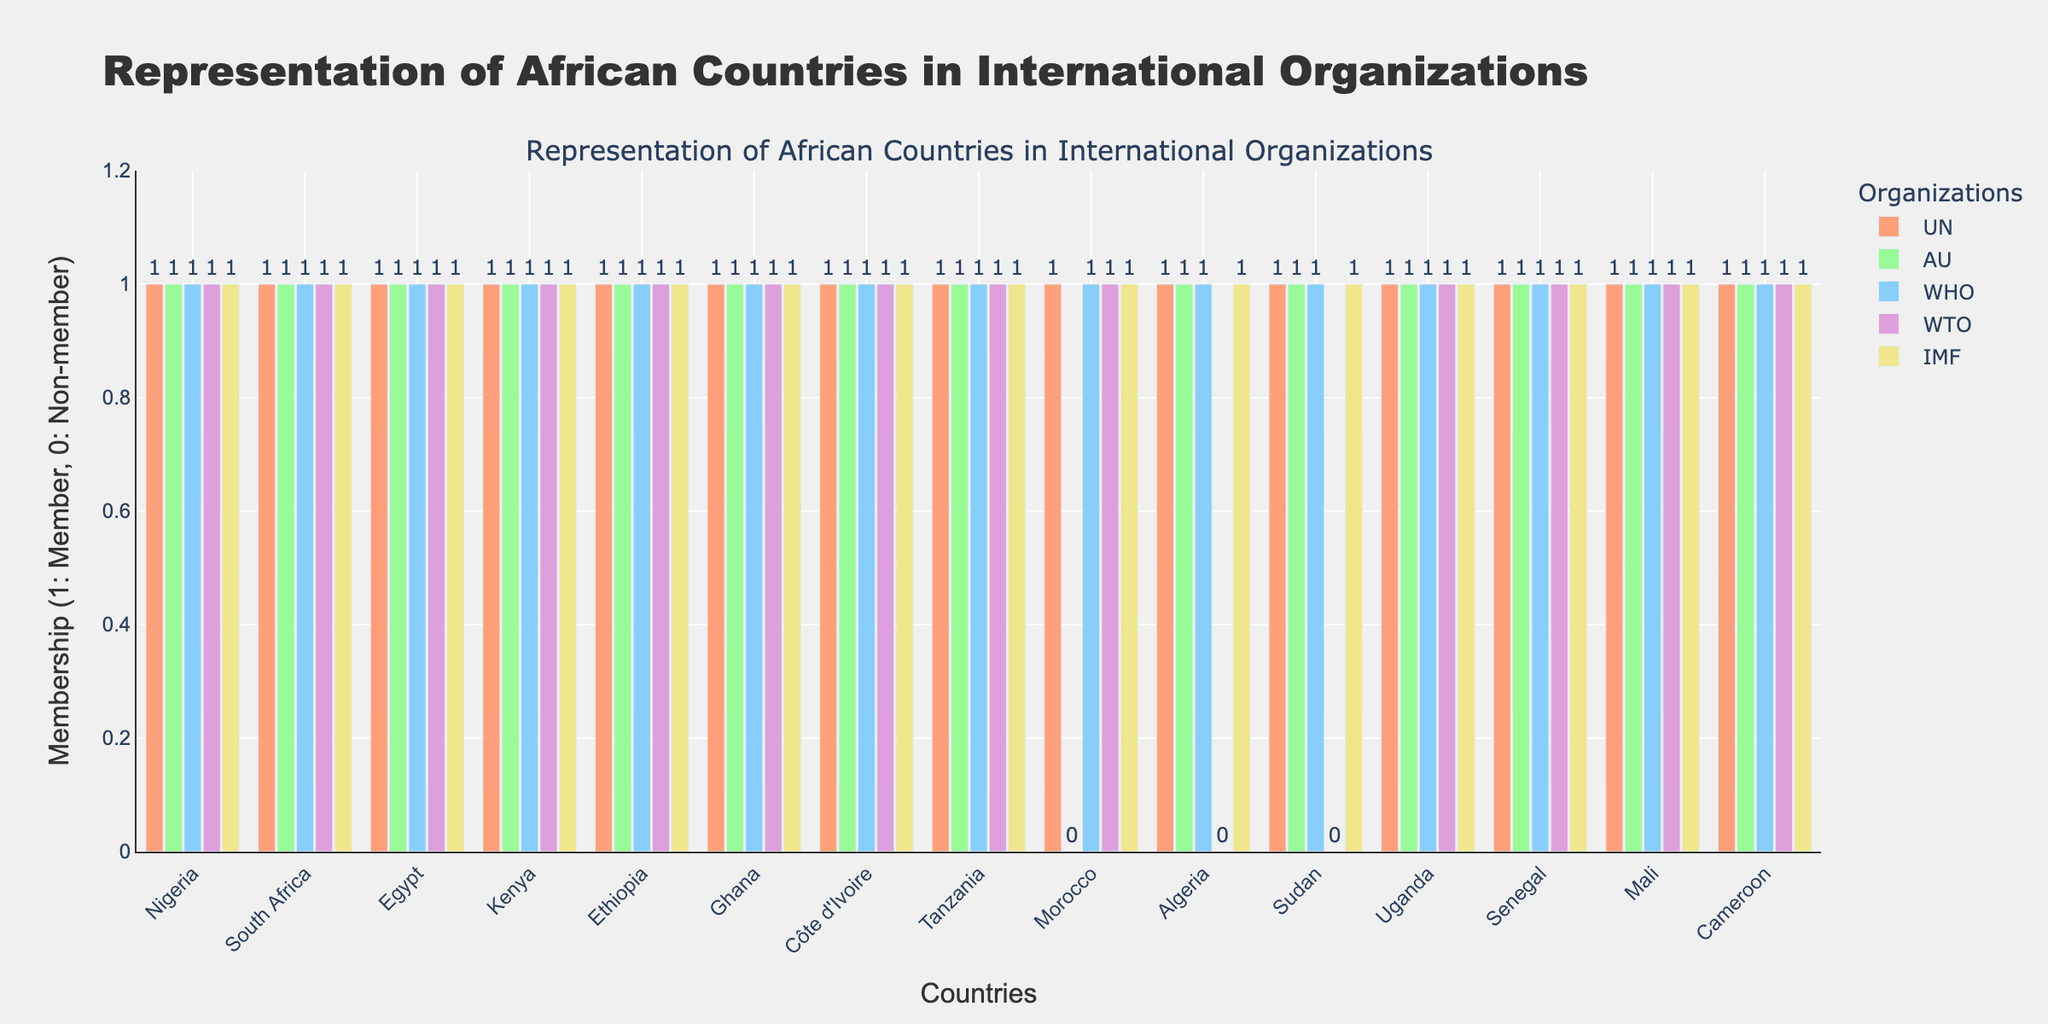What is the total number of countries shown in the chart? Count the number of different countries listed on the x-axis.
Answer: 15 Which country is not a member of the African Union (AU)? Look for the bar representing the AU that does not reach the membership level (1), which is 0.
Answer: Morocco How many countries are members of both the World Bank (WTO) and the International Monetary Fund (IMF)? Identify countries with bars reaching level 1 for both WTO and IMF, then count them.
Answer: 13 Are there any countries that are members of all five international organizations shown in the chart? Check for countries where the bars representing all organizations reach level 1.
Answer: Yes Which international organization has the least representation among the countries in the chart? Look for the organization with the most bars not reaching the level 1 mark.
Answer: WTO Which countries are members of the UN but not the WTO? Look for countries with the UN bar at level 1 but the WTO bar at level 0.
Answer: Algeria, Sudan What is the ratio of countries that are members of the AU to those that are not? Count the number of countries that are members (AU = 1) and not members (AU = 0) and then calculate the ratio. There are 14 members and 1 non-member.
Answer: 14:1 Which organization has the highest overall membership, and what is the total count of its members? Identify the organization with the most bars at level 1 and count the total number of such bars.
Answer: UN, 15 What is the difference in the number of countries that are members of the WHO compared to the IMF? Count the number of countries that are members of the WHO and those that are members of the IMF, then subtract one from the other. Both organizations have 14 members.
Answer: 0 What is the average number of memberships per country across the five organizations? For each country, count the number of memberships where the bar reaches level 1, sum them up for all countries, then divide by the number of countries. There are 72 memberships in total across 15 countries, so 72/15.
Answer: 4.8 